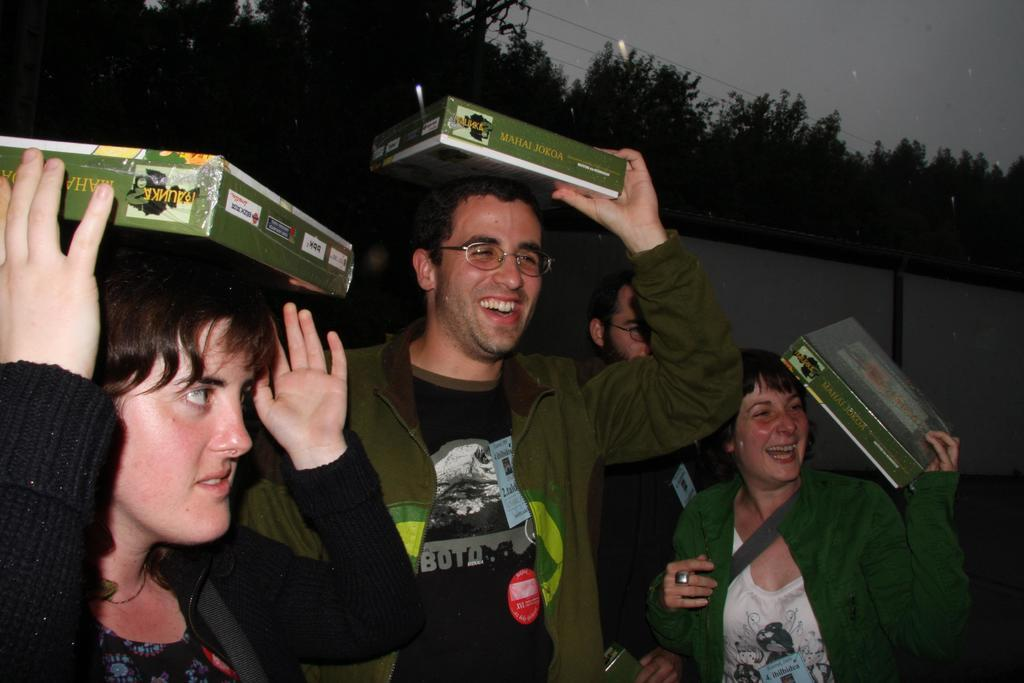What are the people in the image doing? The people in the image are standing and holding cartons. What can be seen in the background of the image? There are trees, wires, and the sky visible in the background of the image. What type of button can be seen on the oven in the image? There is no oven or button present in the image. How many times do the people in the image sneeze? There is no indication of anyone sneezing in the image. 